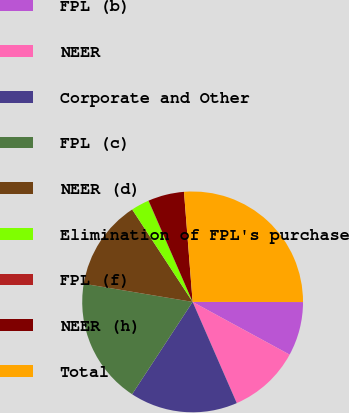<chart> <loc_0><loc_0><loc_500><loc_500><pie_chart><fcel>FPL (b)<fcel>NEER<fcel>Corporate and Other<fcel>FPL (c)<fcel>NEER (d)<fcel>Elimination of FPL's purchase<fcel>FPL (f)<fcel>NEER (h)<fcel>Total<nl><fcel>7.9%<fcel>10.53%<fcel>15.78%<fcel>18.4%<fcel>13.15%<fcel>2.66%<fcel>0.03%<fcel>5.28%<fcel>26.27%<nl></chart> 